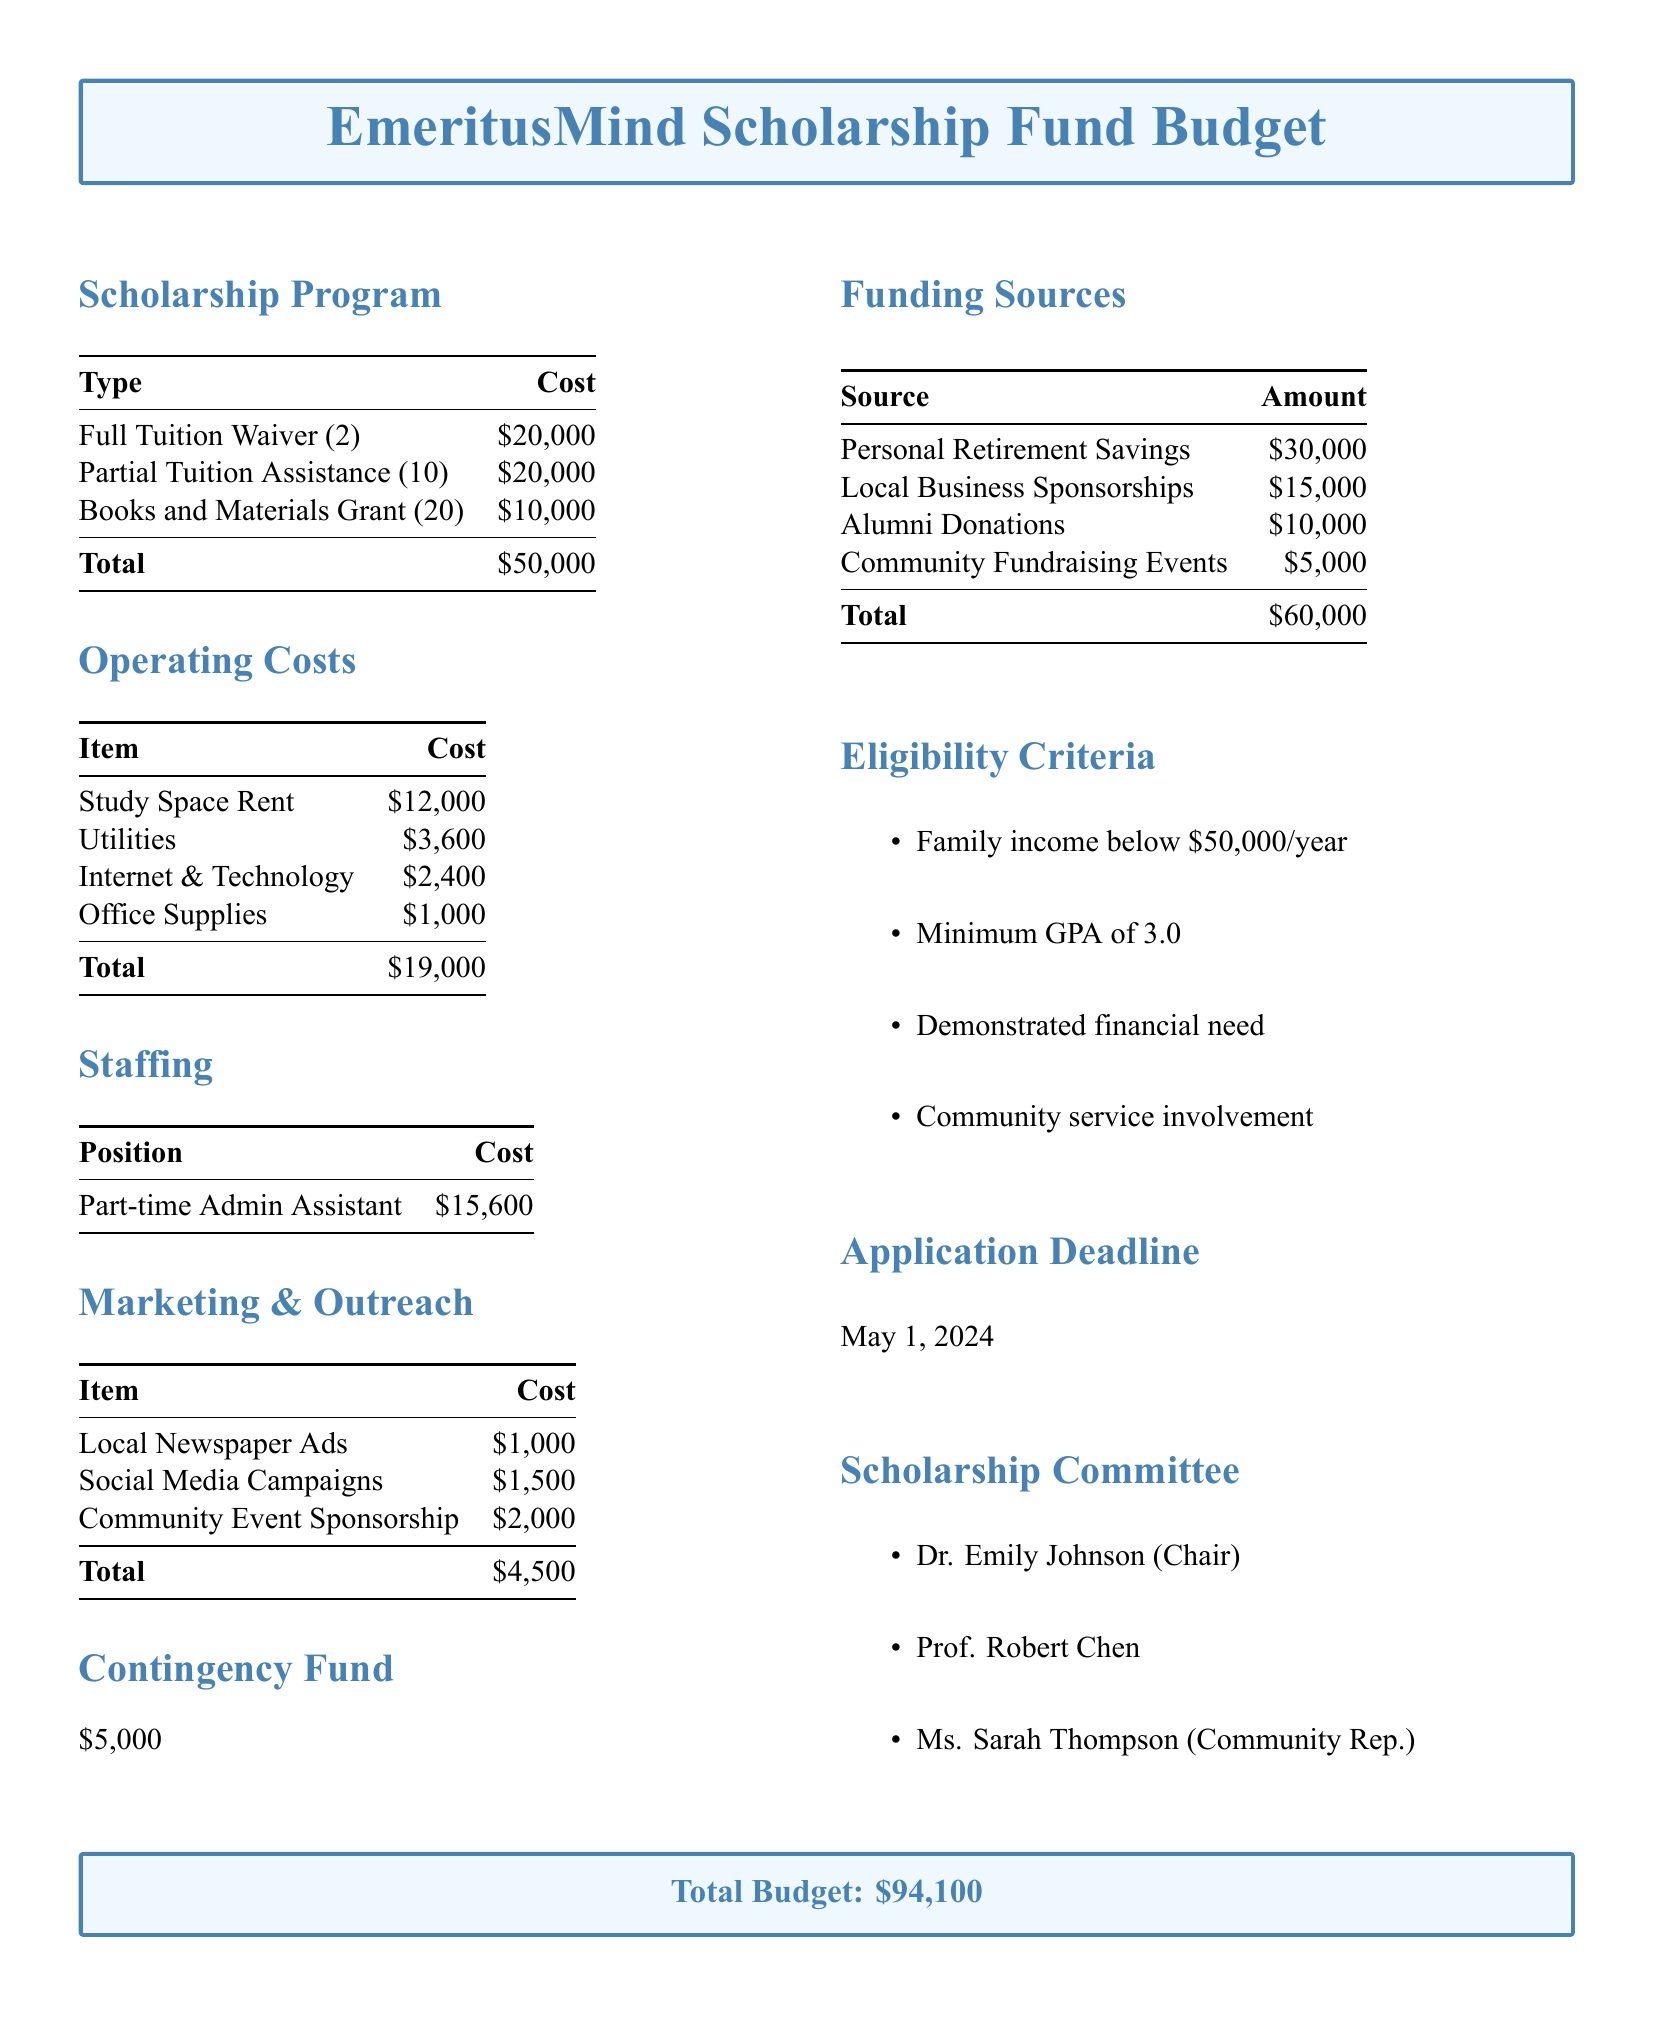what is the total budget? The total budget is stated at the end of the document, summarizing all costs and funding sources.
Answer: $94,100 how many full tuition waivers are offered? This information is specified in the Scholarship Program section, listing the types of scholarships.
Answer: 2 what is the cost of the books and materials grant? The cost for this grant is listed in the Scholarship Program section of the document.
Answer: $10,000 who is the chair of the scholarship committee? This information is provided in the Scholarship Committee section, naming the members.
Answer: Dr. Emily Johnson what is the application deadline? The deadline is noted in the document, indicating when applications must be submitted.
Answer: May 1, 2024 how much is allocated for local newspaper ads in the marketing and outreach section? This cost is detailed in the Marketing & Outreach section of the document.
Answer: $1,000 how many community fundraising events are included in the funding sources? This number can be derived from the Funding Sources section, which lists the sources of funding.
Answer: 1 what is the total cost of Operating Costs? The total is provided at the end of the Operating Costs section.
Answer: $19,000 what percentage of the total budget is designated for scholarships? This requires summing up the costs in the Scholarship Program and dividing by the total budget, found in the document.
Answer: 53% 